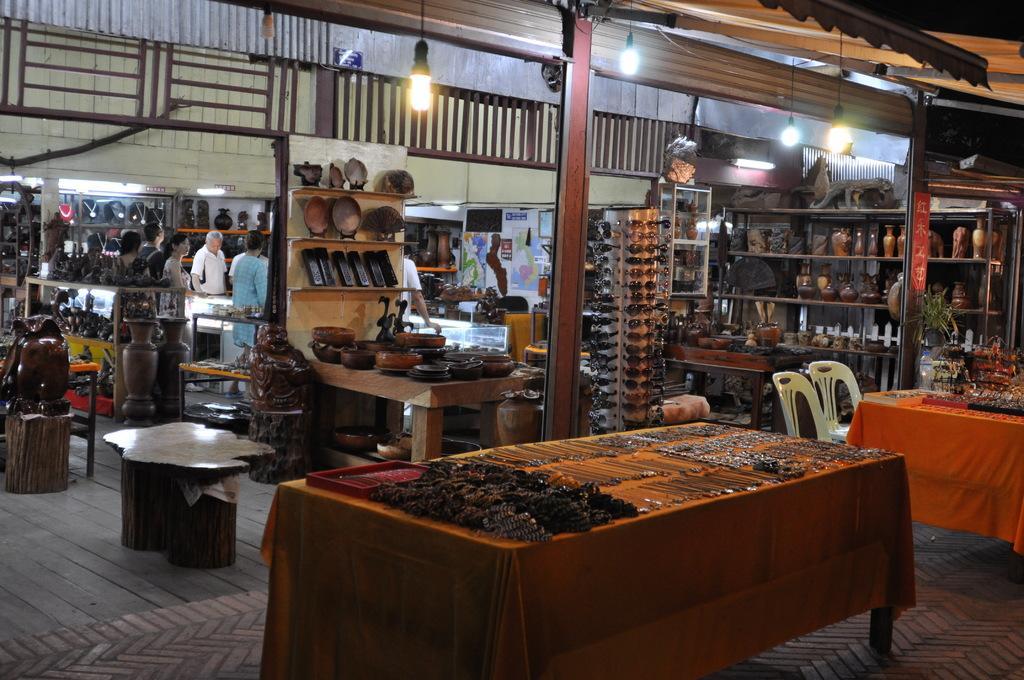How would you summarize this image in a sentence or two? This is a table covered with a orange cloth. There are few kind of ornaments placed on table. These are the two empty chairs. I can see goggles arranged in order. These are the racks with few objects placed inside. This looks like a wooden bench. There are group of people standing here. I can see few posts attached to the wall. These are the lamps hanging to the rooftop. I can see another table covered with cloth and few objects placed on it. This looks like a traditional objects which are kept in the rack. 